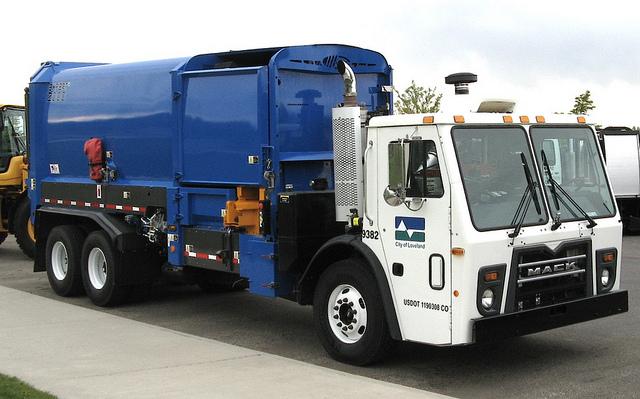What make is this truck?
Concise answer only. Mack. Is the truck blue?
Quick response, please. Yes. Is this a passenger bus?
Short answer required. No. 